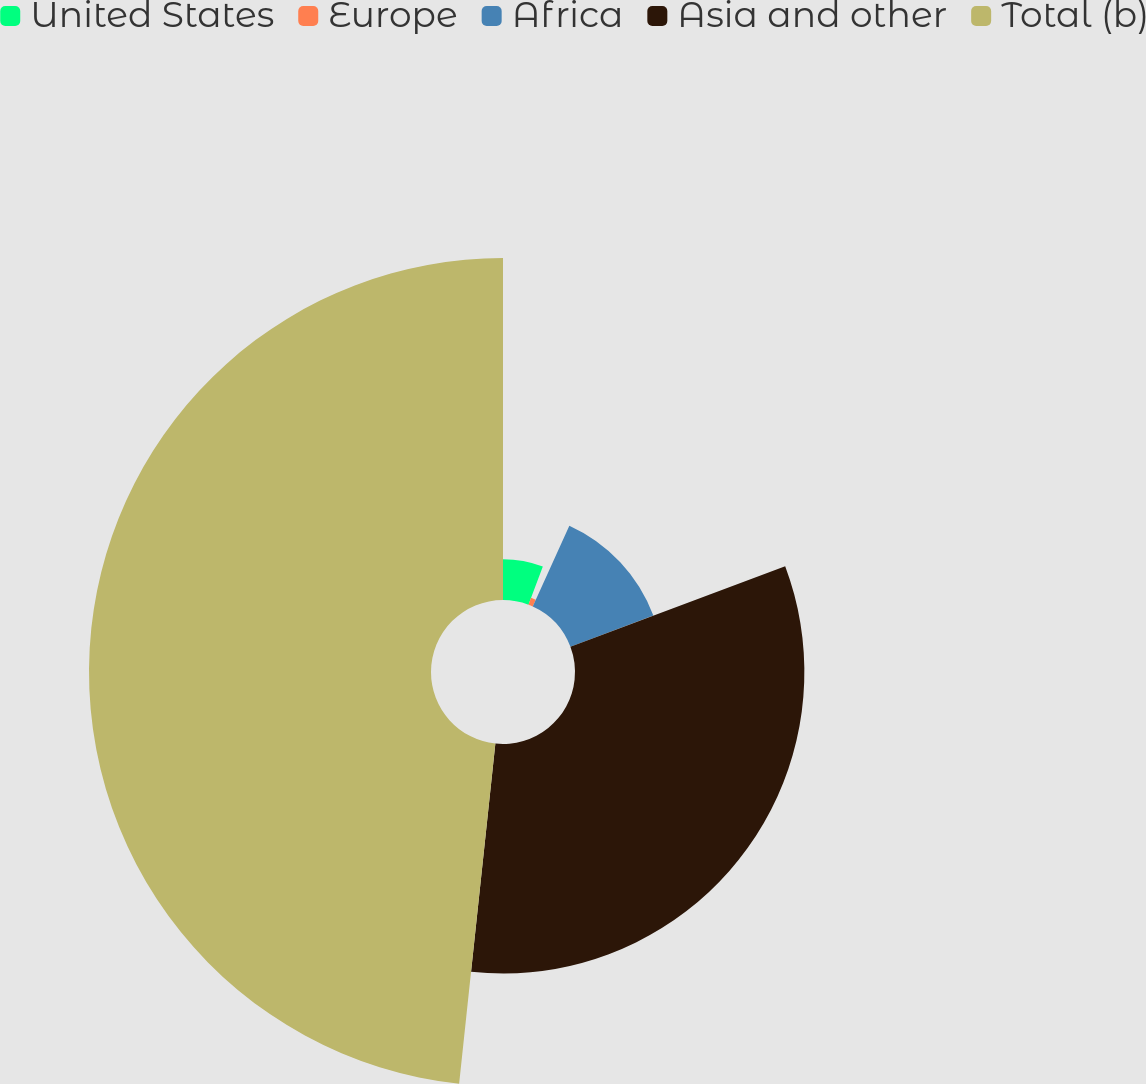Convert chart to OTSL. <chart><loc_0><loc_0><loc_500><loc_500><pie_chart><fcel>United States<fcel>Europe<fcel>Africa<fcel>Asia and other<fcel>Total (b)<nl><fcel>5.75%<fcel>1.03%<fcel>12.51%<fcel>32.4%<fcel>48.31%<nl></chart> 